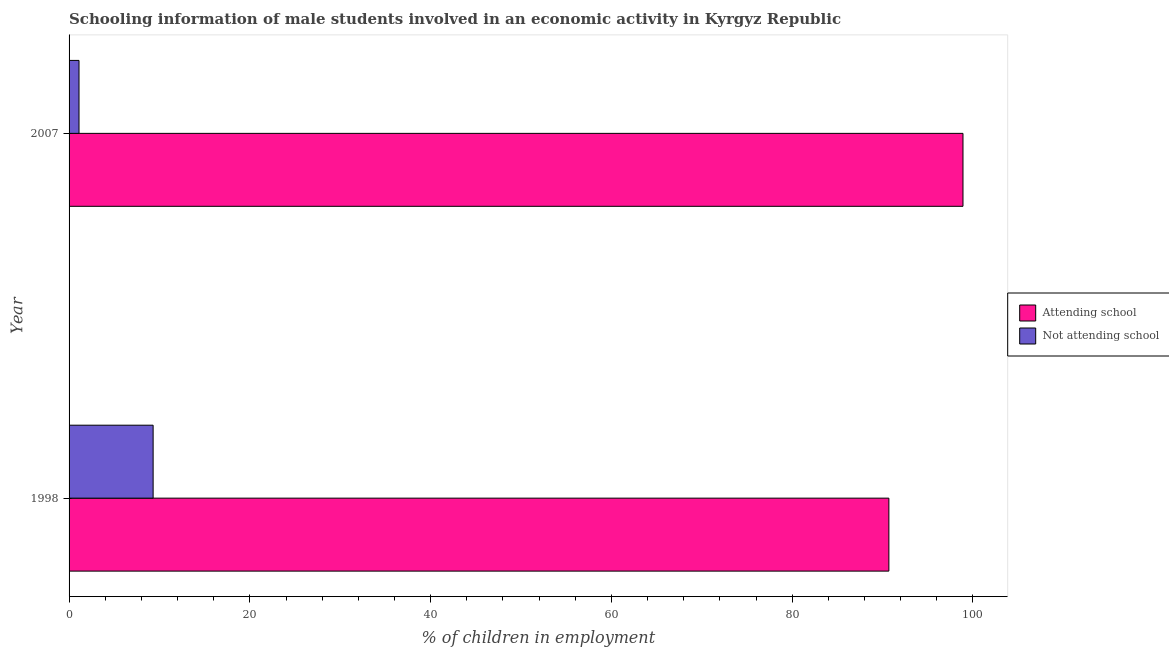How many groups of bars are there?
Make the answer very short. 2. Are the number of bars per tick equal to the number of legend labels?
Keep it short and to the point. Yes. Are the number of bars on each tick of the Y-axis equal?
Give a very brief answer. Yes. How many bars are there on the 2nd tick from the top?
Make the answer very short. 2. What is the label of the 2nd group of bars from the top?
Offer a terse response. 1998. What is the percentage of employed males who are attending school in 1998?
Offer a terse response. 90.7. Across all years, what is the maximum percentage of employed males who are attending school?
Provide a short and direct response. 98.9. Across all years, what is the minimum percentage of employed males who are attending school?
Ensure brevity in your answer.  90.7. What is the total percentage of employed males who are attending school in the graph?
Your answer should be very brief. 189.6. What is the difference between the percentage of employed males who are not attending school in 1998 and that in 2007?
Provide a succinct answer. 8.2. What is the difference between the percentage of employed males who are attending school in 1998 and the percentage of employed males who are not attending school in 2007?
Your answer should be compact. 89.6. What is the average percentage of employed males who are attending school per year?
Make the answer very short. 94.8. In the year 1998, what is the difference between the percentage of employed males who are attending school and percentage of employed males who are not attending school?
Your response must be concise. 81.4. What is the ratio of the percentage of employed males who are not attending school in 1998 to that in 2007?
Provide a short and direct response. 8.46. Is the difference between the percentage of employed males who are not attending school in 1998 and 2007 greater than the difference between the percentage of employed males who are attending school in 1998 and 2007?
Your answer should be very brief. Yes. What does the 2nd bar from the top in 1998 represents?
Offer a very short reply. Attending school. What does the 2nd bar from the bottom in 1998 represents?
Make the answer very short. Not attending school. Are all the bars in the graph horizontal?
Make the answer very short. Yes. What is the difference between two consecutive major ticks on the X-axis?
Your answer should be very brief. 20. Are the values on the major ticks of X-axis written in scientific E-notation?
Your answer should be very brief. No. Does the graph contain any zero values?
Provide a succinct answer. No. Does the graph contain grids?
Your answer should be very brief. No. Where does the legend appear in the graph?
Your response must be concise. Center right. How are the legend labels stacked?
Keep it short and to the point. Vertical. What is the title of the graph?
Provide a short and direct response. Schooling information of male students involved in an economic activity in Kyrgyz Republic. Does "Export" appear as one of the legend labels in the graph?
Keep it short and to the point. No. What is the label or title of the X-axis?
Your response must be concise. % of children in employment. What is the % of children in employment in Attending school in 1998?
Give a very brief answer. 90.7. What is the % of children in employment of Attending school in 2007?
Ensure brevity in your answer.  98.9. What is the % of children in employment in Not attending school in 2007?
Your answer should be very brief. 1.1. Across all years, what is the maximum % of children in employment in Attending school?
Your answer should be very brief. 98.9. Across all years, what is the minimum % of children in employment of Attending school?
Your response must be concise. 90.7. Across all years, what is the minimum % of children in employment of Not attending school?
Your response must be concise. 1.1. What is the total % of children in employment of Attending school in the graph?
Provide a succinct answer. 189.6. What is the total % of children in employment of Not attending school in the graph?
Provide a short and direct response. 10.4. What is the difference between the % of children in employment in Not attending school in 1998 and that in 2007?
Your answer should be compact. 8.2. What is the difference between the % of children in employment in Attending school in 1998 and the % of children in employment in Not attending school in 2007?
Keep it short and to the point. 89.6. What is the average % of children in employment of Attending school per year?
Provide a short and direct response. 94.8. In the year 1998, what is the difference between the % of children in employment in Attending school and % of children in employment in Not attending school?
Ensure brevity in your answer.  81.4. In the year 2007, what is the difference between the % of children in employment in Attending school and % of children in employment in Not attending school?
Provide a short and direct response. 97.8. What is the ratio of the % of children in employment of Attending school in 1998 to that in 2007?
Your answer should be very brief. 0.92. What is the ratio of the % of children in employment in Not attending school in 1998 to that in 2007?
Provide a short and direct response. 8.45. What is the difference between the highest and the second highest % of children in employment of Not attending school?
Your response must be concise. 8.2. 